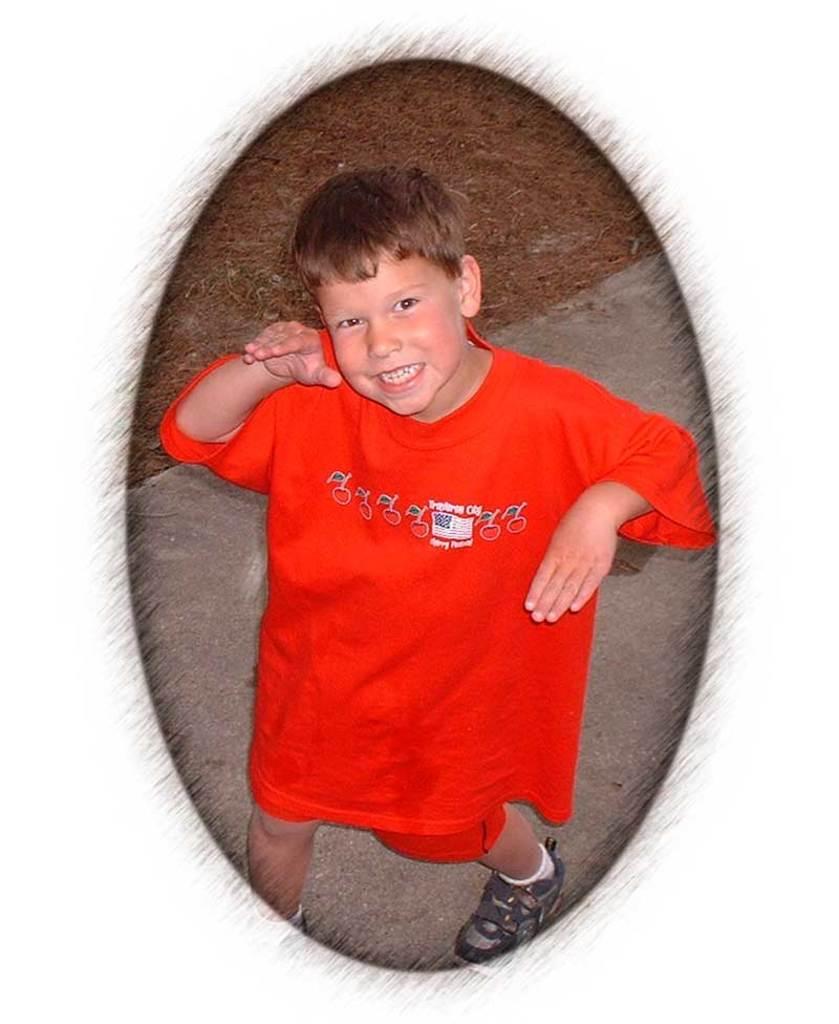Describe this image in one or two sentences. In this image we can see one boy in red dress with smiling face dancing on the road and some dried grass on the ground. 